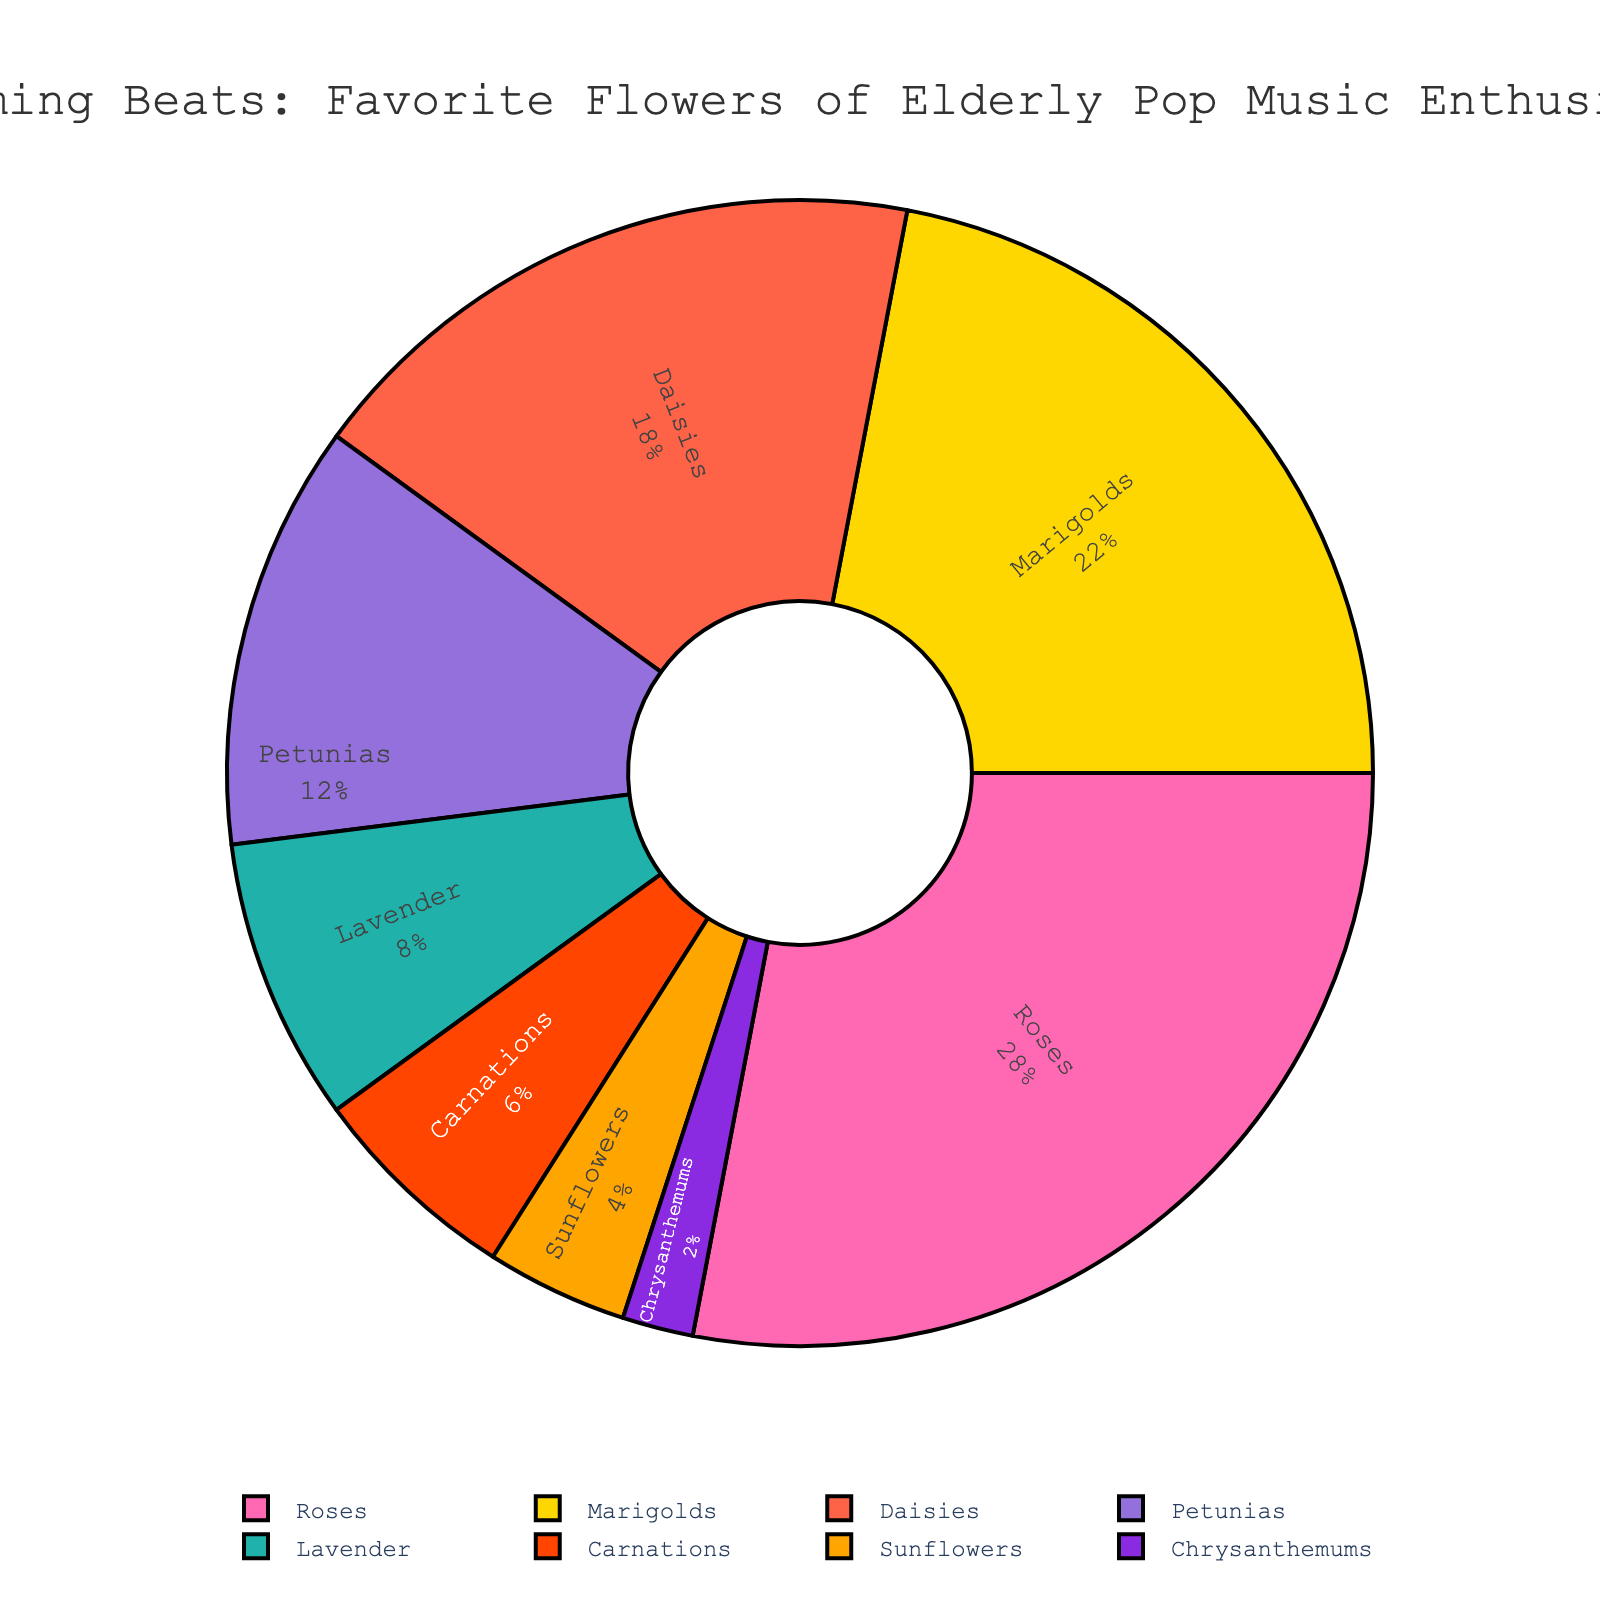Which flower has the highest percentage in the chart? The chart shows different flower types with their respective percentages. The flower with the highest percentage will have the largest slice in the pie chart.
Answer: Roses What is the combined percentage of Petunias and Lavender? To find the combined percentage, add the percentages of Petunias and Lavender as shown on the chart. Petunias have 12% and Lavender has 8%. 12% + 8% = 20%
Answer: 20% Which flower has a larger percentage: Sunflowers or Carnations? Compare the percentage values of Sunflowers and Carnations. The chart shows that Carnations have 6% and Sunflowers have 4%. Since 6% is greater than 4%, Carnations have a larger percentage.
Answer: Carnations How many different types of flowers make up more than 10% each of the total? Identify each flower that has a percentage greater than 10% in the pie chart. From the chart, Roses have 28%, Marigolds have 22%, and Daisies have 18%. There are 3 types of flowers with more than 10%.
Answer: 3 What is the total percentage covered by flowers other than Roses, Marigolds, and Daisies? First, sum the percentages of Roses, Marigolds, and Daisies, which are 28%, 22%, and 18%, respectively. Add these to get 68% (28% + 22% + 18% = 68%). Subtract this sum from 100% to find the percentage covered by the other flowers: 100% - 68% = 32%.
Answer: 32% Which flower is represented by the smallest slice in the pie chart? The flower with the smallest percentage will have the smallest slice in the pie chart. From the chart, Chrysanthemums have the smallest percentage at 2%.
Answer: Chrysanthemums Is the difference in percentage between Marigolds and Petunias greater than or less than 15%? Calculate the difference between the percentages of Marigolds and Petunias: 22% (Marigolds) - 12% (Petunias) = 10%. Since 10% is less than 15%, the difference is less than 15%.
Answer: Less than 15% Which flowers are represented by slices that are visually yellow and purple in the chart? From the pie chart colors, identify the flowers that match the yellow and purple slices. Marigolds are yellow, and Petunias are purple.
Answer: Marigolds and Petunias What is the percentage difference between Roses and Daisies? Subtract the percentage of Daisies from the percentage of Roses: 28% (Roses) - 18% (Daisies) = 10%. The difference is 10%.
Answer: 10% 